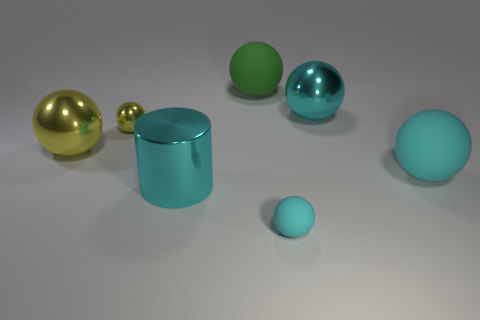Is the large green object the same shape as the large yellow metal thing?
Offer a terse response. Yes. Do the large green object and the small object behind the cyan cylinder have the same material?
Give a very brief answer. No. What is the material of the tiny cyan sphere?
Your answer should be very brief. Rubber. There is a tiny ball left of the big matte object that is behind the big metallic object that is on the right side of the small cyan rubber thing; what is its material?
Keep it short and to the point. Metal. There is a green object that is the same size as the cyan shiny ball; what shape is it?
Offer a very short reply. Sphere. How many things are large metal things or big metal spheres behind the large yellow metal ball?
Ensure brevity in your answer.  3. Are the small ball to the right of the cyan metallic cylinder and the cyan object behind the big yellow metal object made of the same material?
Your response must be concise. No. There is another metal thing that is the same color as the small metal thing; what is its shape?
Ensure brevity in your answer.  Sphere. What number of yellow objects are big things or cylinders?
Your response must be concise. 1. What size is the cyan shiny cylinder?
Make the answer very short. Large. 